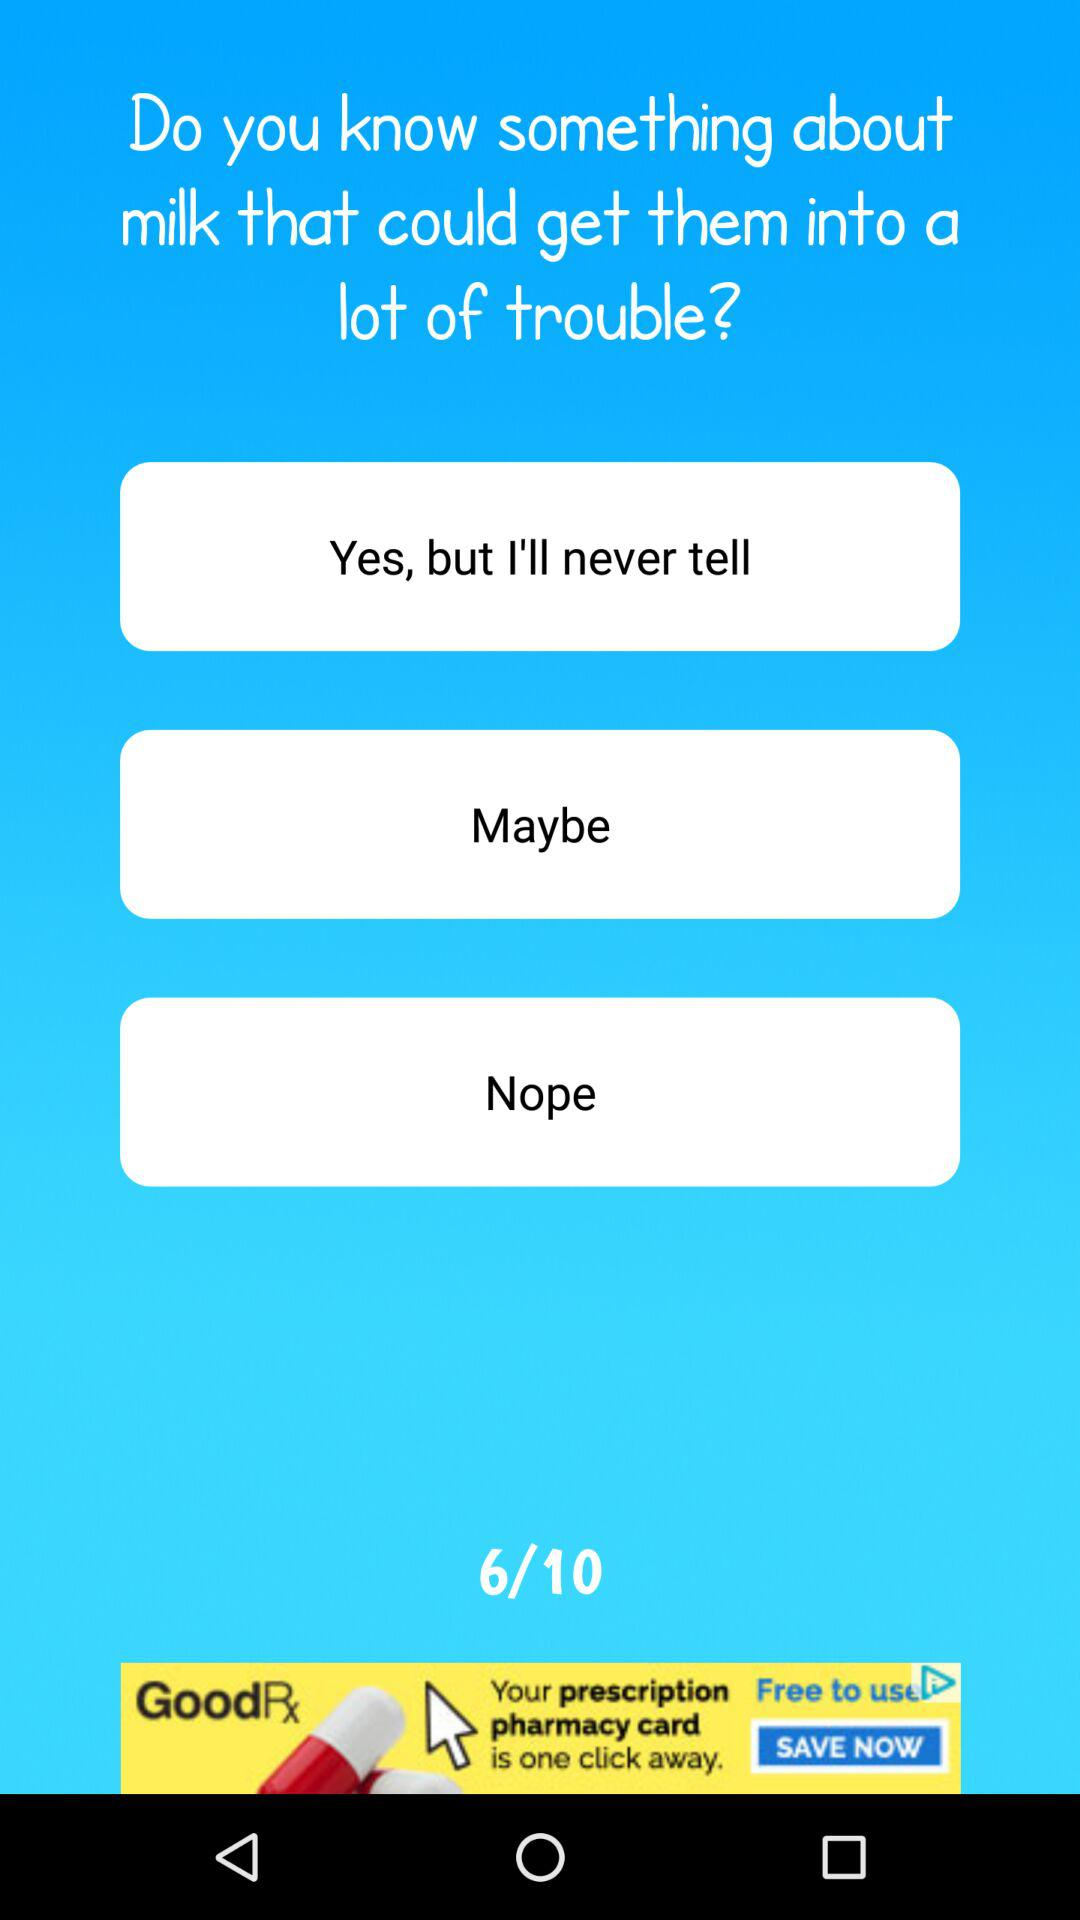What is the average rating of the app?
Answer the question using a single word or phrase. 6/10 